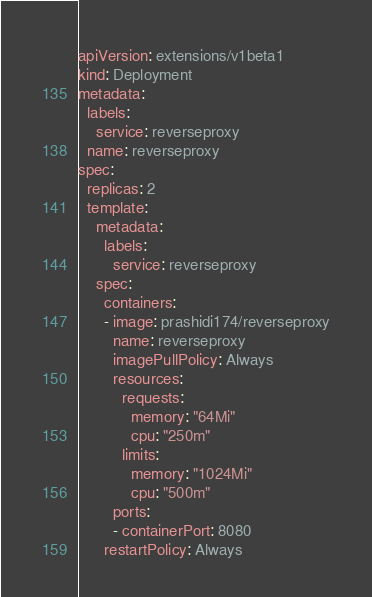<code> <loc_0><loc_0><loc_500><loc_500><_YAML_>apiVersion: extensions/v1beta1
kind: Deployment
metadata:
  labels:
    service: reverseproxy
  name: reverseproxy
spec:
  replicas: 2
  template:
    metadata:
      labels:
        service: reverseproxy
    spec:
      containers:
      - image: prashidi174/reverseproxy
        name: reverseproxy
        imagePullPolicy: Always          
        resources:
          requests:
            memory: "64Mi"
            cpu: "250m"
          limits:
            memory: "1024Mi"
            cpu: "500m"       
        ports:
        - containerPort: 8080
      restartPolicy: Always</code> 